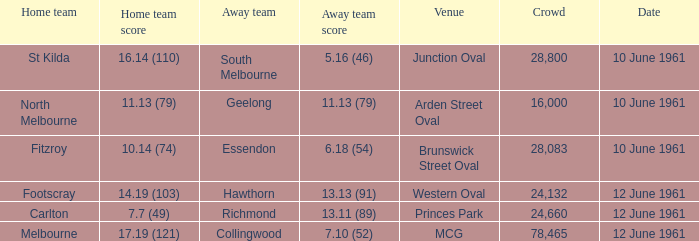In which place can you find a gathering of over 16,000 people and a home team with a 7.7 (49) score? Princes Park. 